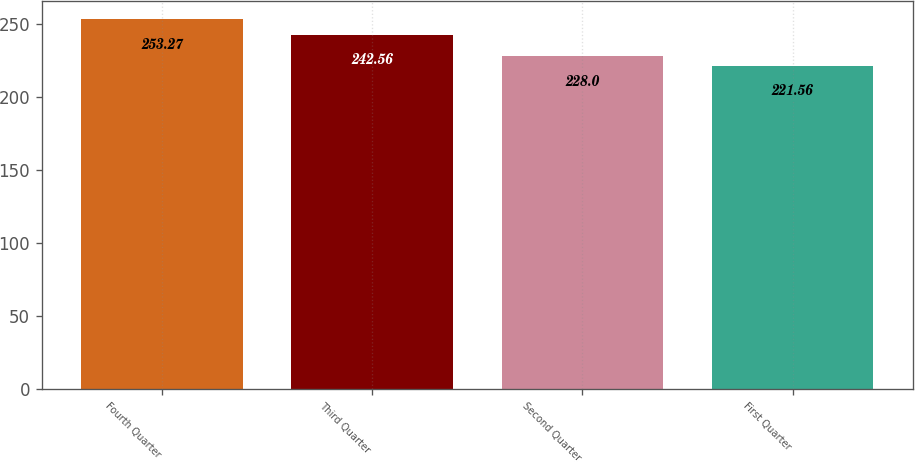Convert chart to OTSL. <chart><loc_0><loc_0><loc_500><loc_500><bar_chart><fcel>Fourth Quarter<fcel>Third Quarter<fcel>Second Quarter<fcel>First Quarter<nl><fcel>253.27<fcel>242.56<fcel>228<fcel>221.56<nl></chart> 